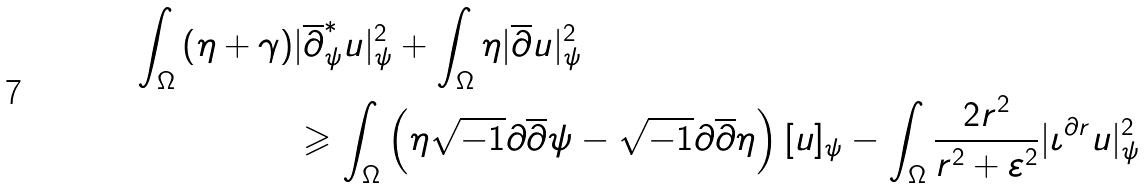Convert formula to latex. <formula><loc_0><loc_0><loc_500><loc_500>\int _ { \Omega } \left ( \eta + \gamma \right ) & | \overline { \partial } ^ { * } _ { \psi } { u } | ^ { 2 } _ { \psi } + \int _ { \Omega } \eta | \overline { \partial } { u } | ^ { 2 } _ { \psi } \\ & \geqslant \int _ { \Omega } \left ( \eta \sqrt { - 1 } \partial \overline { \partial } \psi - \sqrt { - 1 } \partial \overline { \partial } \eta \right ) [ u ] _ { \psi } - \int _ { \Omega } \frac { 2 r ^ { 2 } } { r ^ { 2 } + \varepsilon ^ { 2 } } | \iota ^ { \partial { r } } u | _ { \psi } ^ { 2 }</formula> 